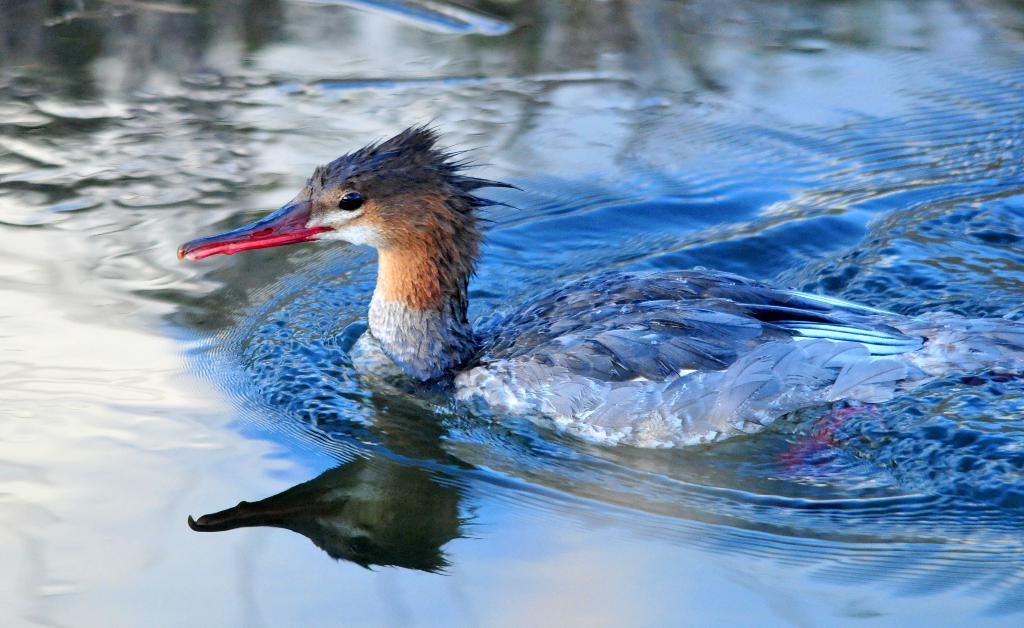What animal is present in the image? There is a duck in the image. Where is the duck located in the image? The duck is on the surface of the water. What is the duck's tendency to interact with the zebra in the image? There is no zebra present in the image, so the duck's tendency to interact with a zebra cannot be determined. 